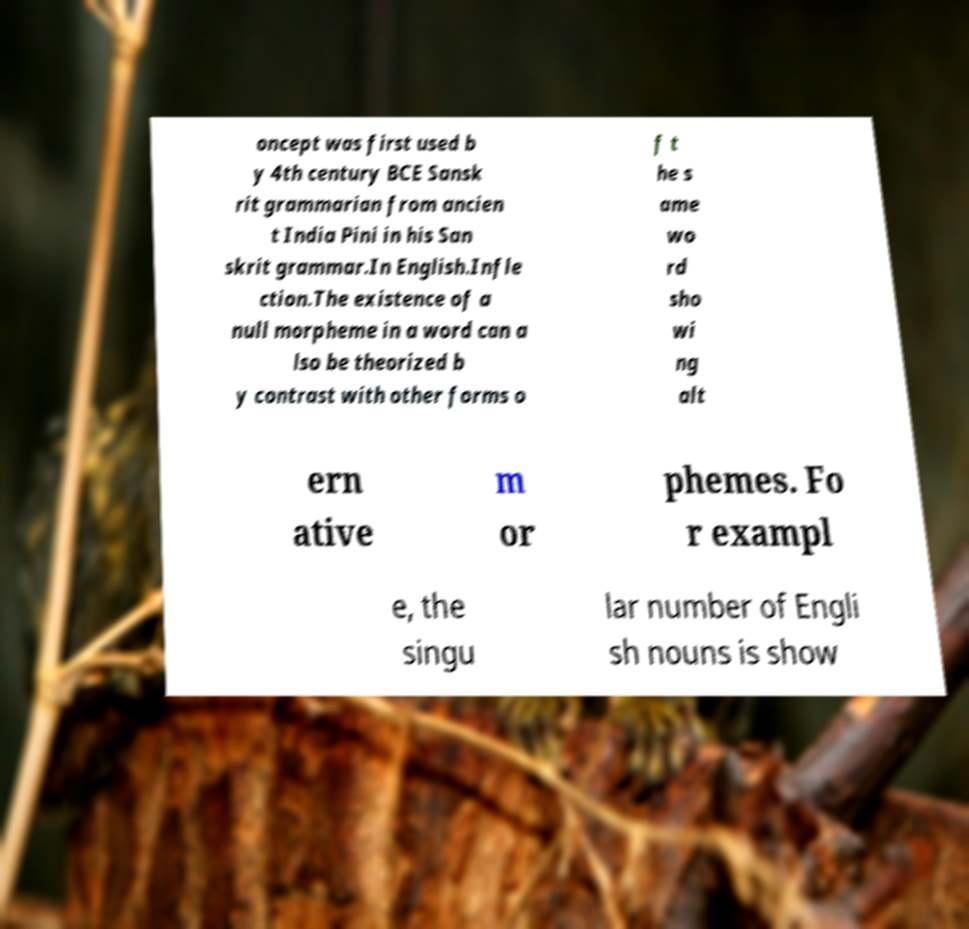I need the written content from this picture converted into text. Can you do that? oncept was first used b y 4th century BCE Sansk rit grammarian from ancien t India Pini in his San skrit grammar.In English.Infle ction.The existence of a null morpheme in a word can a lso be theorized b y contrast with other forms o f t he s ame wo rd sho wi ng alt ern ative m or phemes. Fo r exampl e, the singu lar number of Engli sh nouns is show 